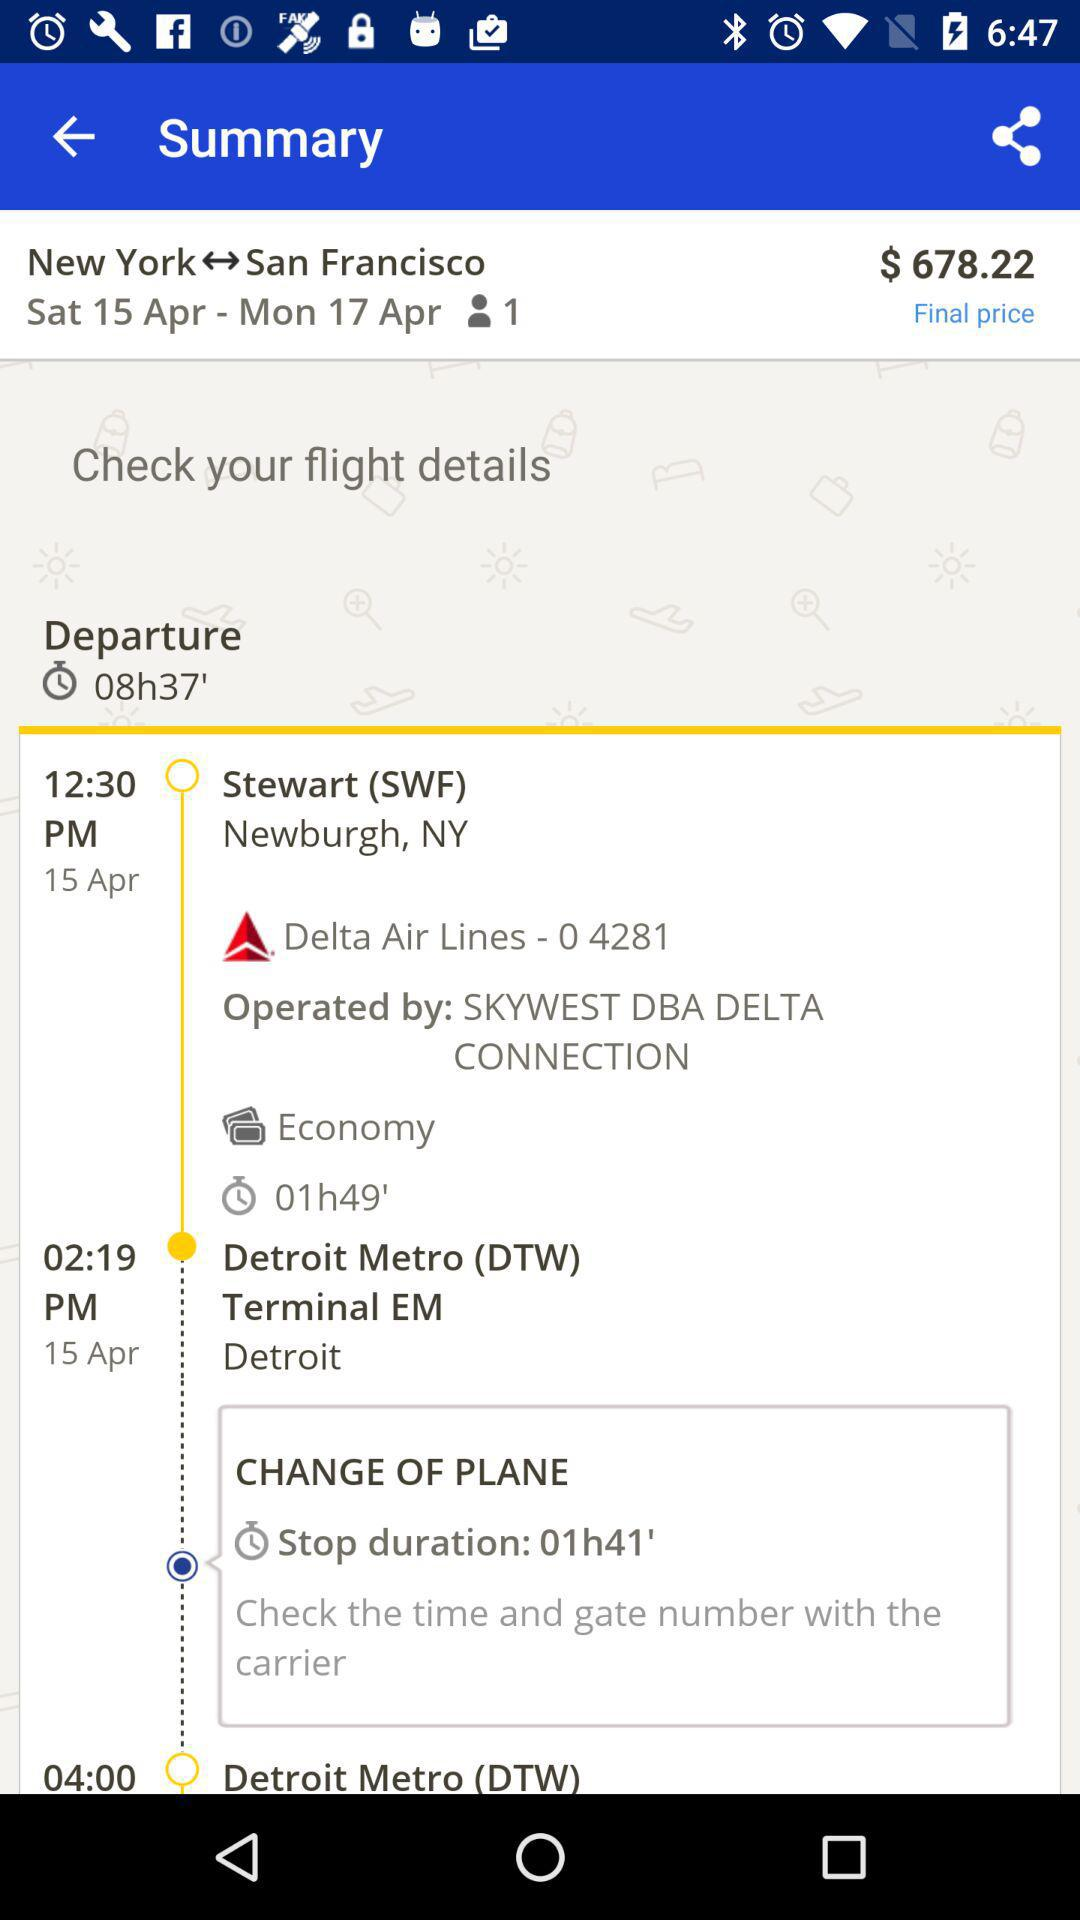What is the final price? The final price is $678.22. 